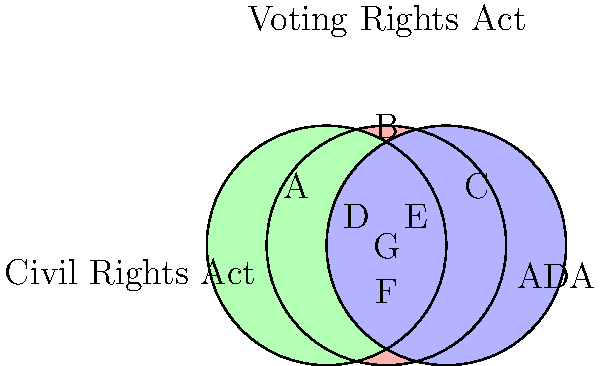In the Venn diagram above, three major civil rights acts are represented: the Civil Rights Act, the Americans with Disabilities Act (ADA), and the Voting Rights Act. Each region (A through G) represents different combinations of protections offered by these acts. Which region represents individuals who are protected by all three acts simultaneously? To answer this question, we need to analyze the Venn diagram and understand the overlapping regions:

1. The red circle represents the Civil Rights Act.
2. The green circle represents the Americans with Disabilities Act (ADA).
3. The blue circle represents the Voting Rights Act.

4. Region A is exclusively covered by the Civil Rights Act.
5. Region B is exclusively covered by the Voting Rights Act.
6. Region C is exclusively covered by the ADA.
7. Region D is covered by both the Civil Rights Act and the Voting Rights Act.
8. Region E is covered by both the Voting Rights Act and the ADA.
9. Region F is covered by both the Civil Rights Act and the ADA.
10. Region G is at the center where all three circles overlap.

The question asks for the region where individuals are protected by all three acts simultaneously. This would be the area where all three circles intersect, which is region G in the center of the diagram.

As civil rights attorneys experienced in constitutional law cases, it's crucial to recognize this overlap, as it represents individuals who may have multiple grounds for protection under various civil rights acts. This understanding can be vital in developing comprehensive legal strategies for clients facing discrimination on multiple fronts.
Answer: G 